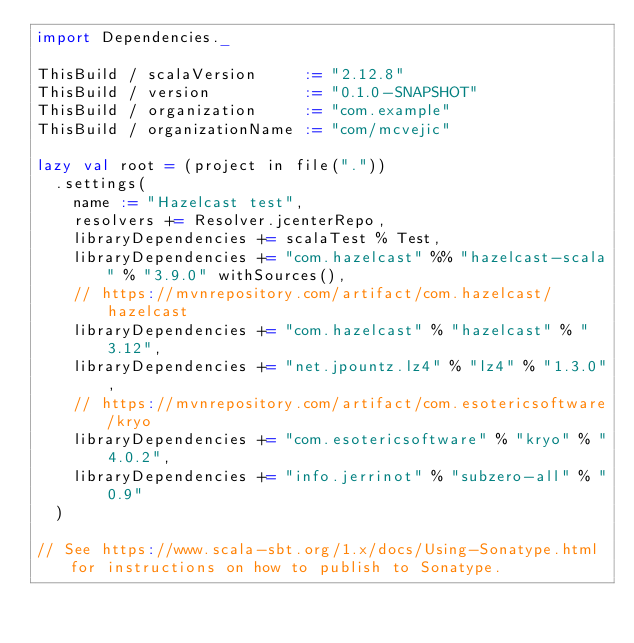<code> <loc_0><loc_0><loc_500><loc_500><_Scala_>import Dependencies._

ThisBuild / scalaVersion     := "2.12.8"
ThisBuild / version          := "0.1.0-SNAPSHOT"
ThisBuild / organization     := "com.example"
ThisBuild / organizationName := "com/mcvejic"

lazy val root = (project in file("."))
  .settings(
    name := "Hazelcast test",
    resolvers += Resolver.jcenterRepo,
    libraryDependencies += scalaTest % Test,
    libraryDependencies += "com.hazelcast" %% "hazelcast-scala" % "3.9.0" withSources(),
    // https://mvnrepository.com/artifact/com.hazelcast/hazelcast
    libraryDependencies += "com.hazelcast" % "hazelcast" % "3.12",
    libraryDependencies += "net.jpountz.lz4" % "lz4" % "1.3.0",
    // https://mvnrepository.com/artifact/com.esotericsoftware/kryo
    libraryDependencies += "com.esotericsoftware" % "kryo" % "4.0.2",
    libraryDependencies += "info.jerrinot" % "subzero-all" % "0.9"
  )

// See https://www.scala-sbt.org/1.x/docs/Using-Sonatype.html for instructions on how to publish to Sonatype.
</code> 